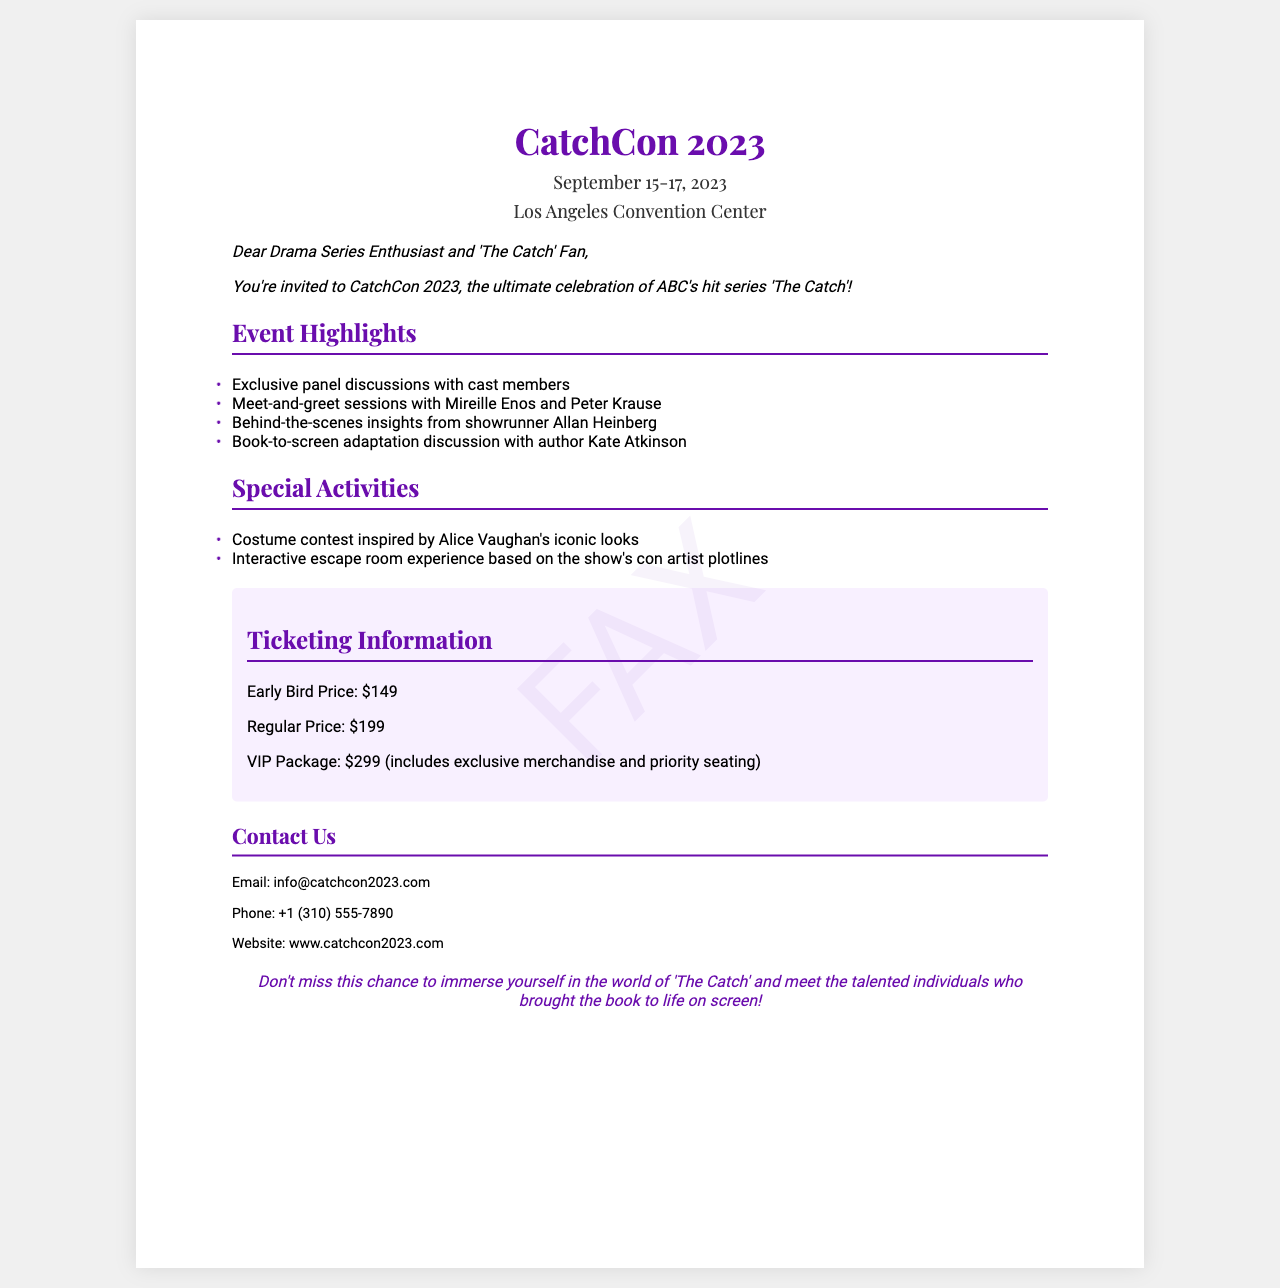what is the name of the event? The name of the event is prominently featured in the heading of the document.
Answer: CatchCon 2023 where is the convention taking place? The location of the convention is mentioned under the event details in the document.
Answer: Los Angeles Convention Center who are two cast members mentioned for meet-and-greets? The document lists specific cast members for meet-and-greet sessions under event highlights.
Answer: Mireille Enos and Peter Krause what is the early bird ticket price? The ticket pricing information includes the early bird ticket price, which is explicitly stated in the document.
Answer: $149 who is the showrunner providing insights? The showrunner is identified in the event highlights section.
Answer: Allan Heinberg what type of contest is featured at the convention? A specific activity is described as a contest in the special activities section.
Answer: Costume contest what is included in the VIP package? The document describes what the VIP package entails under the ticketing information section.
Answer: Exclusive merchandise and priority seating how many days does the convention last? The duration of the event is specified in the event title section.
Answer: Three days what should fans not miss during the event? The closing statement emphasizes what fans can look forward to during the event.
Answer: Immersing in the world of 'The Catch' 